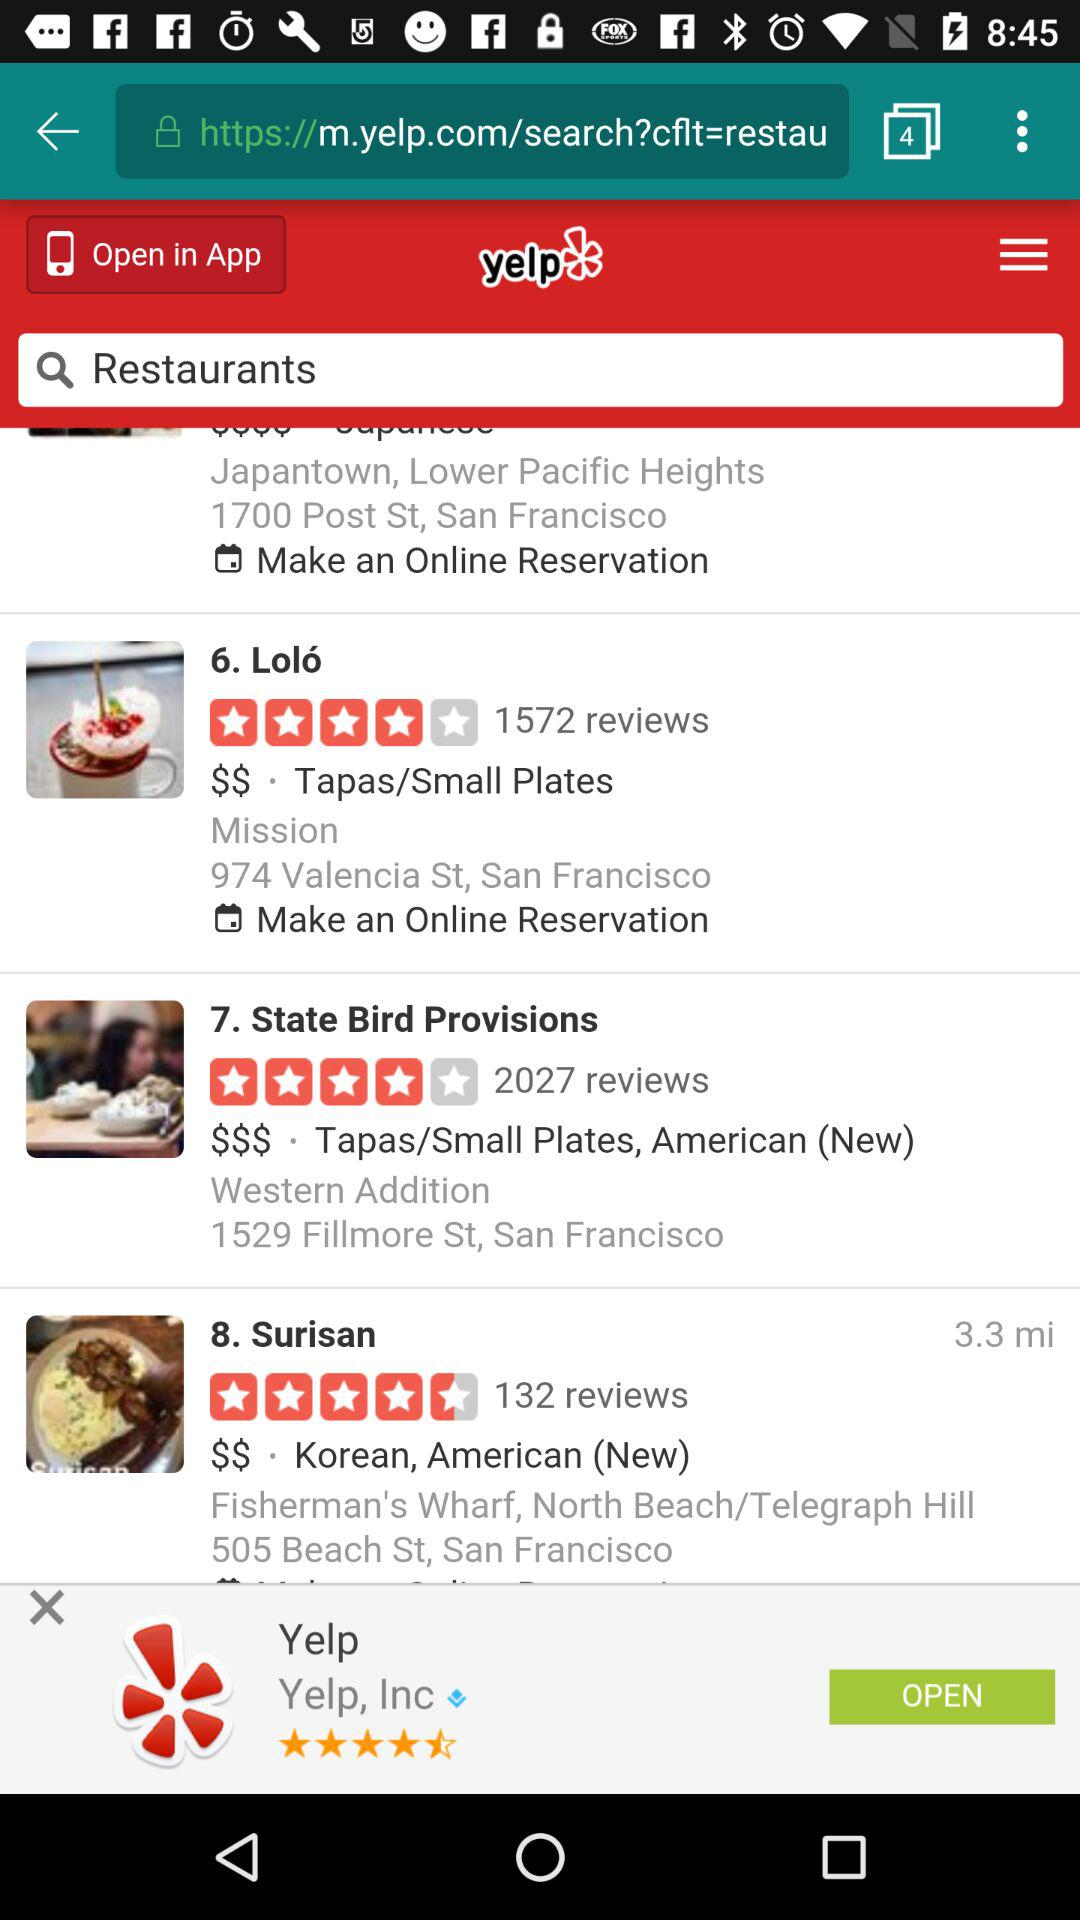Which hotel have the highest rating?
When the provided information is insufficient, respond with <no answer>. <no answer> 